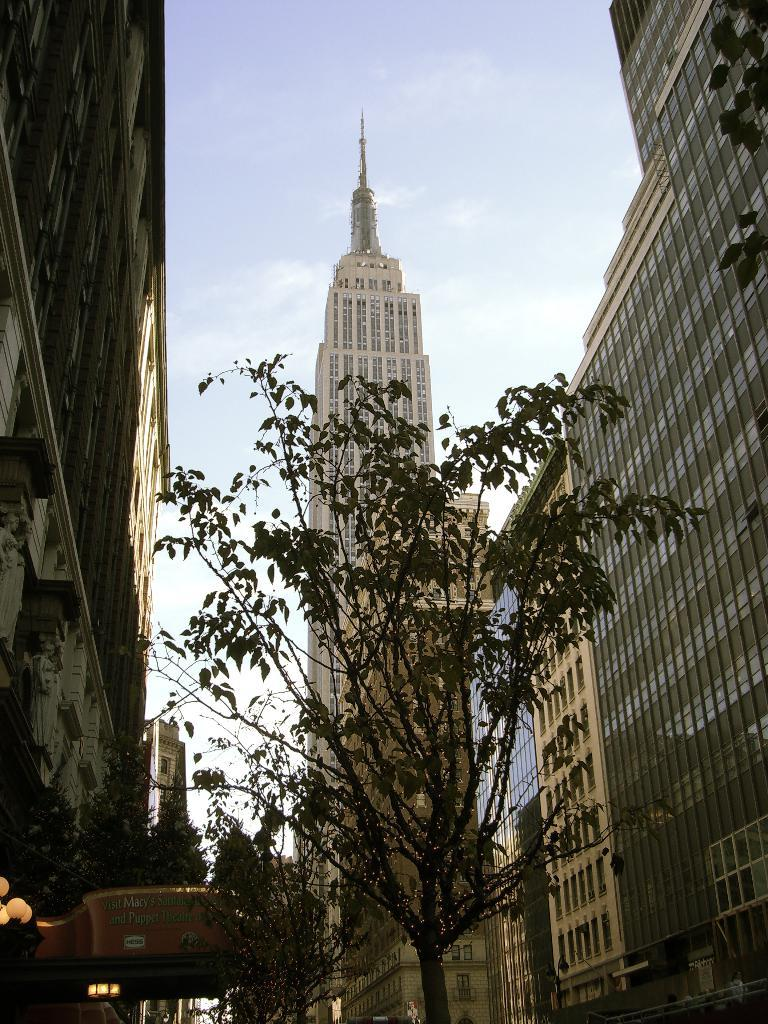What type of natural elements can be seen in the image? There are trees in the image. What type of man-made structures are present in the image? There are buildings on the sides of the image and a building in the background of the image. Where is the light pole located in the image? The light pole is in the left bottom corner of the image. What is visible in the background of the image? The sky is visible in the background of the image. What time of day is the writer working in the image? There is no writer present in the image, so it is not possible to determine the time of day they might be working. What historical event is depicted in the image? There is no historical event depicted in the image; it features trees, buildings, a light pole, and the sky. 